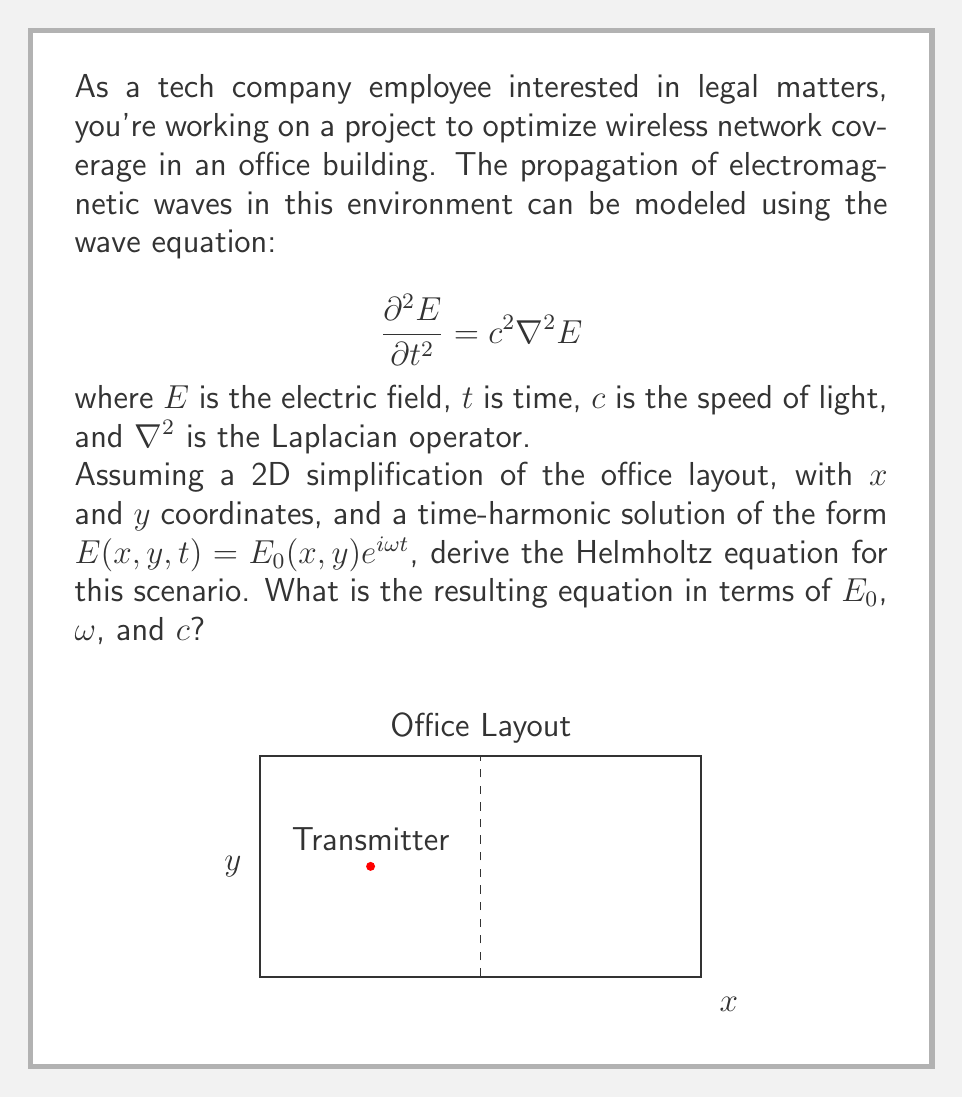Provide a solution to this math problem. Let's approach this step-by-step:

1) We start with the wave equation:
   $$\frac{\partial^2 E}{\partial t^2} = c^2 \nabla^2 E$$

2) We assume a time-harmonic solution of the form:
   $$E(x,y,t) = E_0(x,y)e^{i\omega t}$$

3) Let's substitute this into the wave equation. First, we need to calculate $\frac{\partial^2 E}{\partial t^2}$:
   $$\frac{\partial E}{\partial t} = i\omega E_0(x,y)e^{i\omega t}$$
   $$\frac{\partial^2 E}{\partial t^2} = -\omega^2 E_0(x,y)e^{i\omega t}$$

4) The right-hand side of the wave equation becomes:
   $$c^2 \nabla^2 E = c^2 \nabla^2 (E_0(x,y)e^{i\omega t}) = c^2 (\nabla^2 E_0(x,y)) e^{i\omega t}$$

5) Substituting these back into the wave equation:
   $$-\omega^2 E_0(x,y)e^{i\omega t} = c^2 (\nabla^2 E_0(x,y)) e^{i\omega t}$$

6) The $e^{i\omega t}$ terms cancel out on both sides:
   $$-\omega^2 E_0(x,y) = c^2 \nabla^2 E_0(x,y)$$

7) Rearranging the terms:
   $$\nabla^2 E_0(x,y) + \frac{\omega^2}{c^2} E_0(x,y) = 0$$

This is the Helmholtz equation for our 2D scenario.
Answer: $$\nabla^2 E_0 + \frac{\omega^2}{c^2} E_0 = 0$$ 